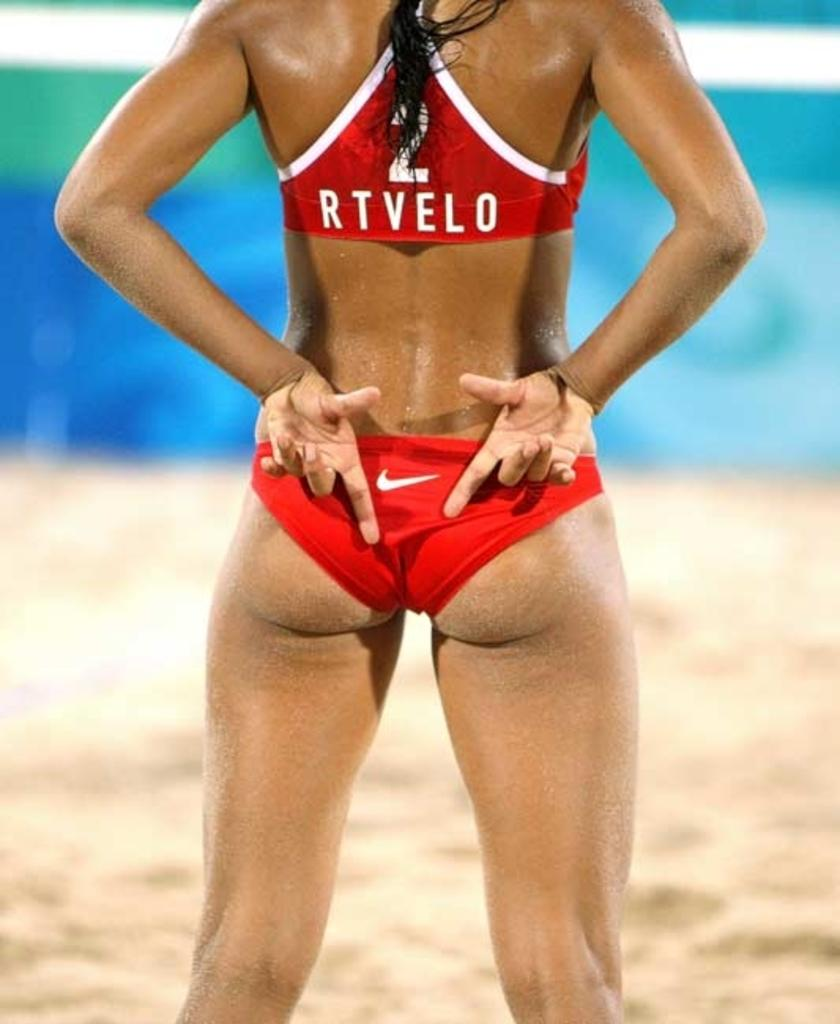<image>
Present a compact description of the photo's key features. The back of a girl showing that is wearing a twp piece red and white bathing suit that has the #2 written above RTVELO on the top. 